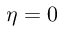<formula> <loc_0><loc_0><loc_500><loc_500>\eta = 0</formula> 